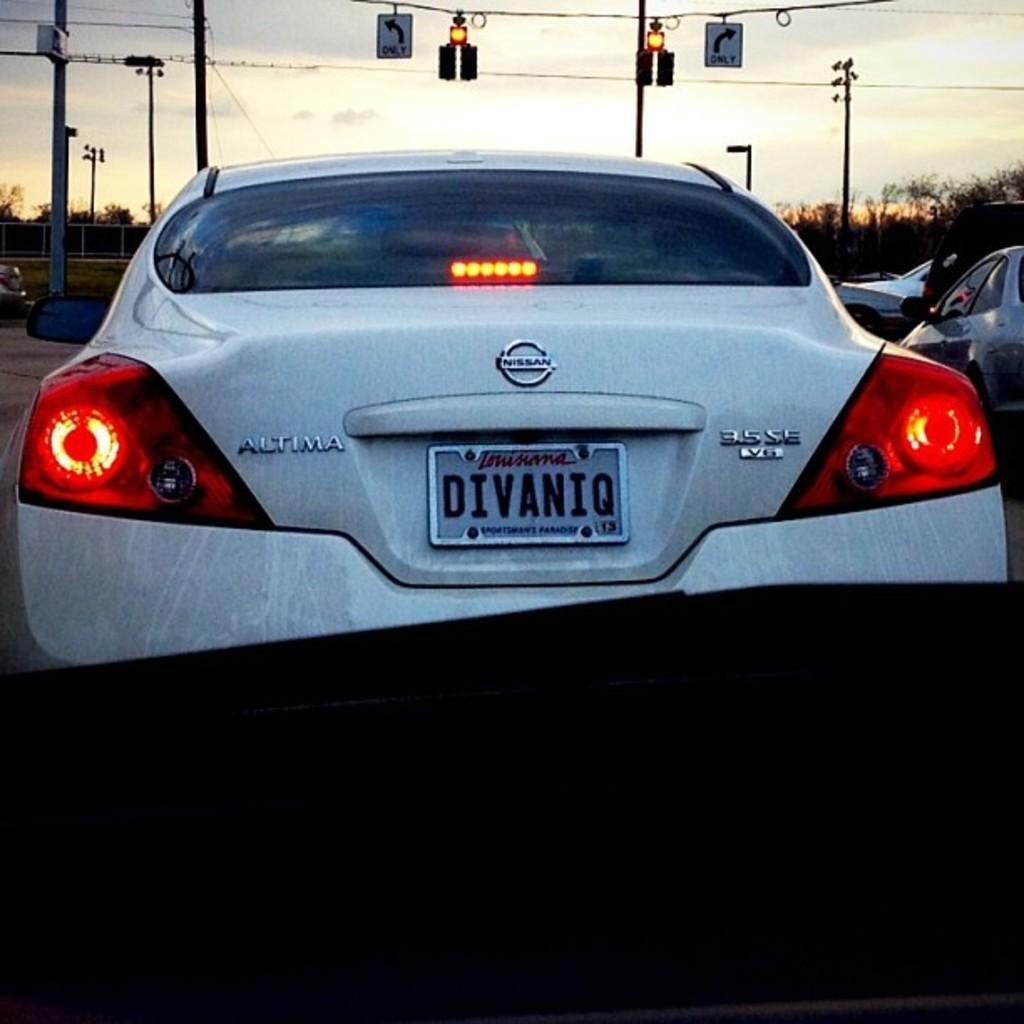Please provide a concise description of this image. In this image there are a few vehicles on the road. In the background there is a railing and trees. At the top of the image there are signals and sign boards. 